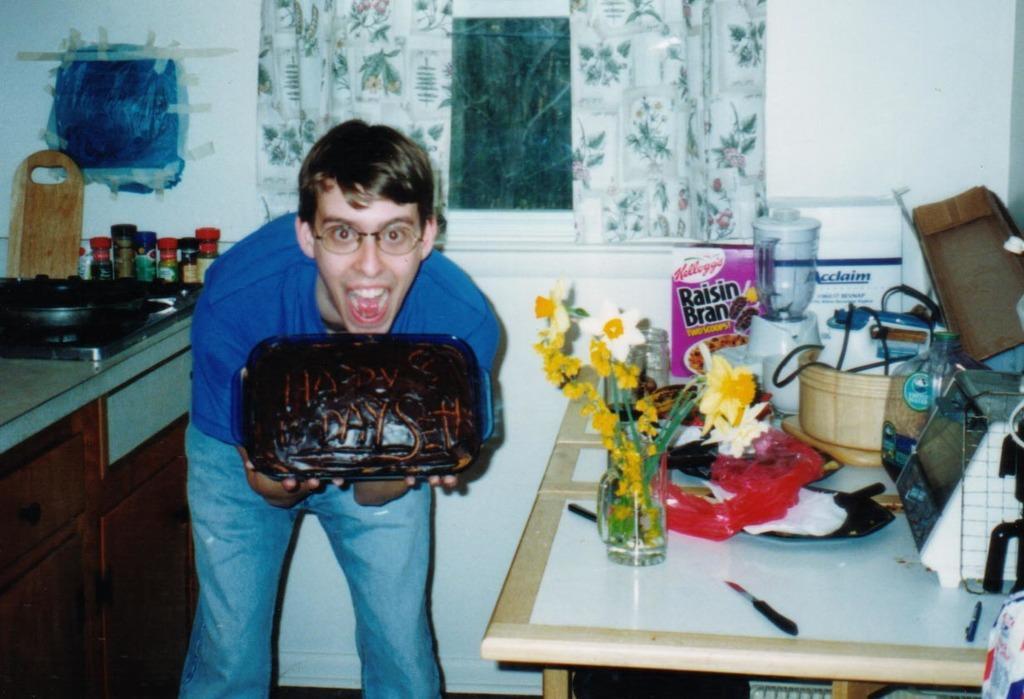In one or two sentences, can you explain what this image depicts? In this picture there is a boy at the left side of the boy and he is holding a cake in his hands, and there is a table at the right side of the image where there is a flower pot and other kitchenware items and there is a window at the center of the image behind the boy and there is a desk at the left side of the image. 